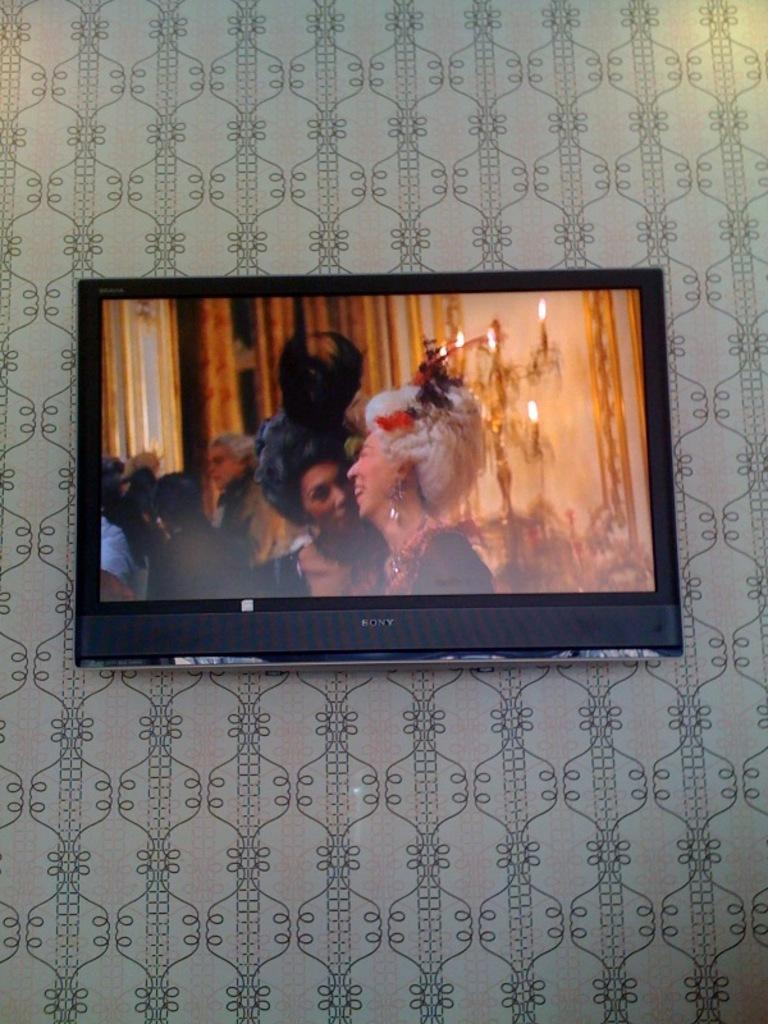What electronic device is present in the image? There is a television in the image. How is the television positioned in the image? The television is attached to the wall. What is being displayed on the television? The television is displaying a picture of people. What type of sock is being used to rest the television on the wall? There is no sock present in the image, and the television is not being rested on anything; it is attached to the wall. 